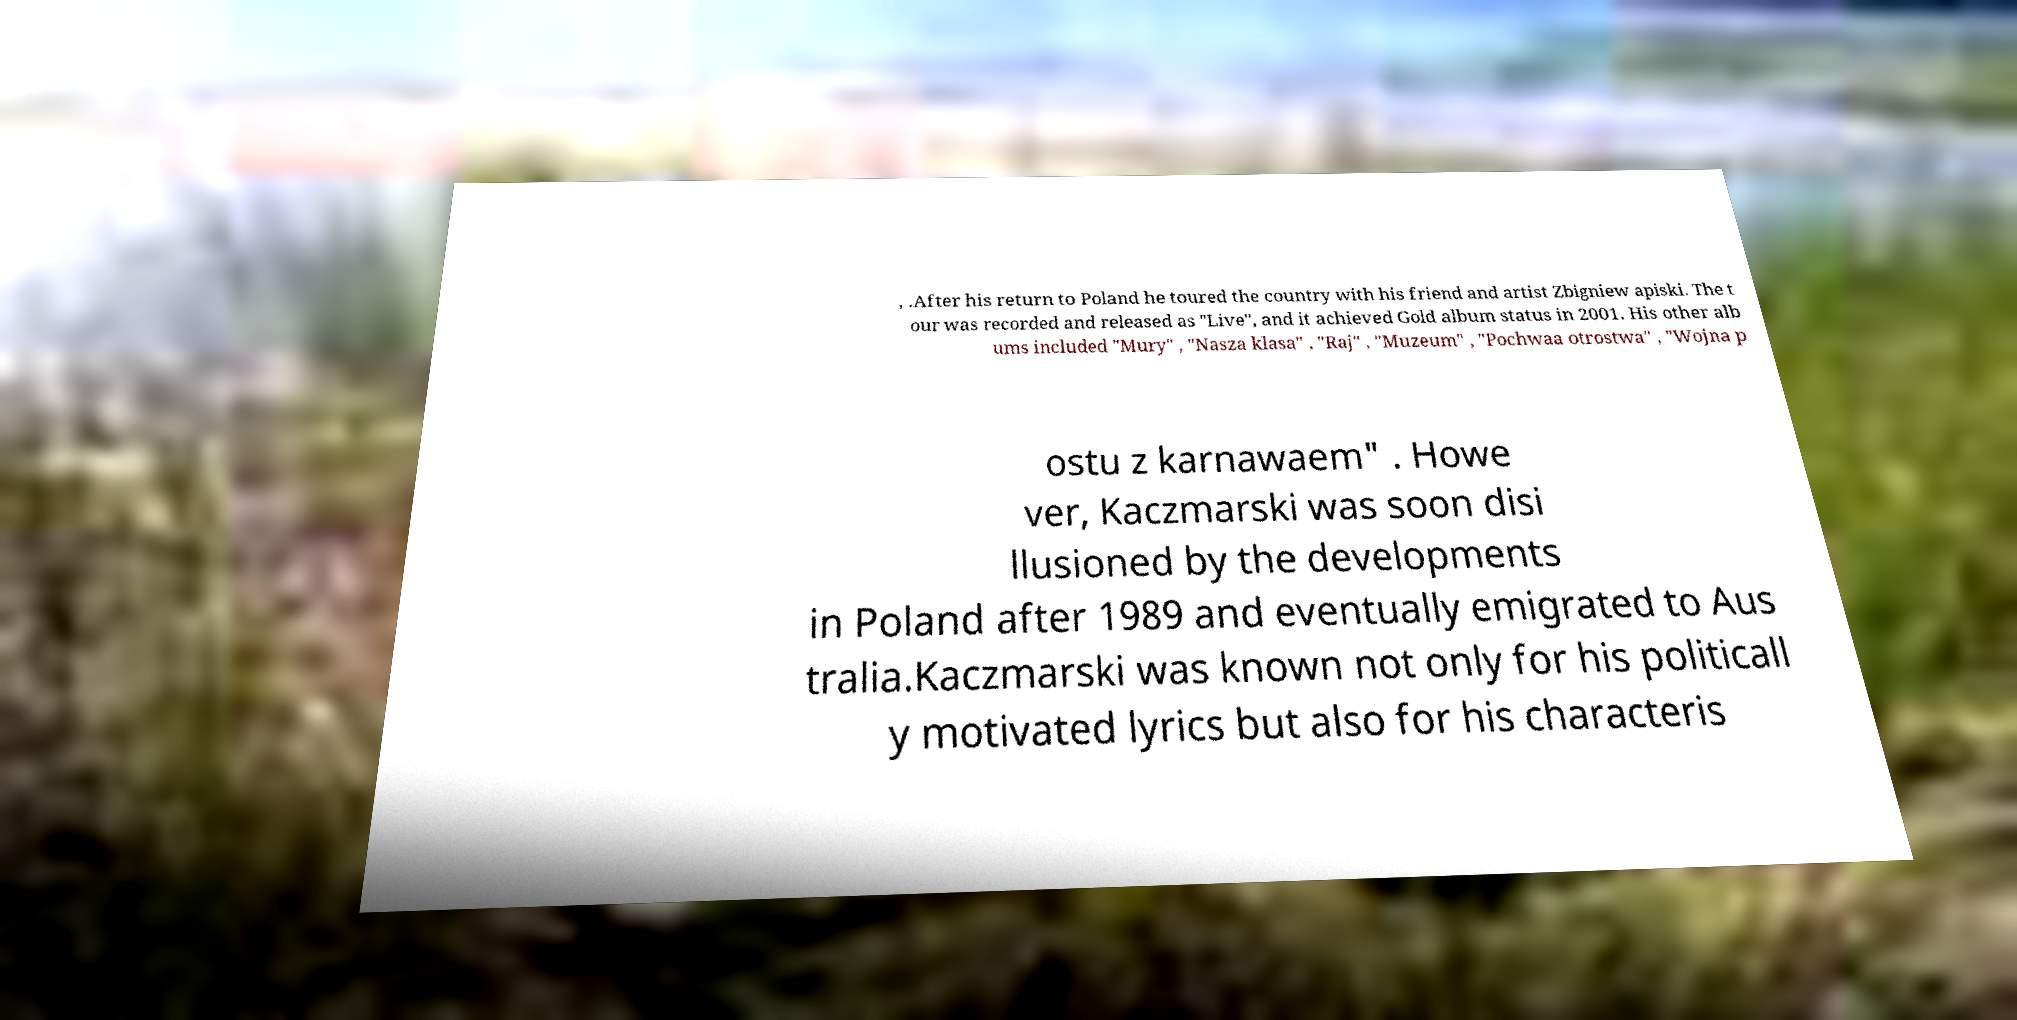I need the written content from this picture converted into text. Can you do that? , .After his return to Poland he toured the country with his friend and artist Zbigniew apiski. The t our was recorded and released as "Live", and it achieved Gold album status in 2001. His other alb ums included "Mury" , "Nasza klasa" , "Raj" , "Muzeum" , "Pochwaa otrostwa" , "Wojna p ostu z karnawaem" . Howe ver, Kaczmarski was soon disi llusioned by the developments in Poland after 1989 and eventually emigrated to Aus tralia.Kaczmarski was known not only for his politicall y motivated lyrics but also for his characteris 